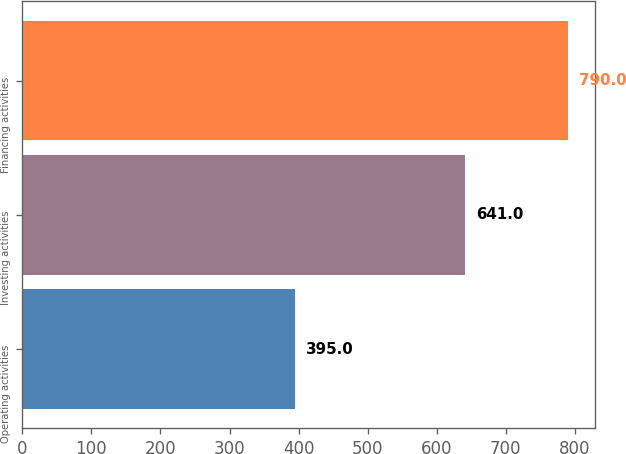Convert chart. <chart><loc_0><loc_0><loc_500><loc_500><bar_chart><fcel>Operating activities<fcel>Investing activities<fcel>Financing activities<nl><fcel>395<fcel>641<fcel>790<nl></chart> 